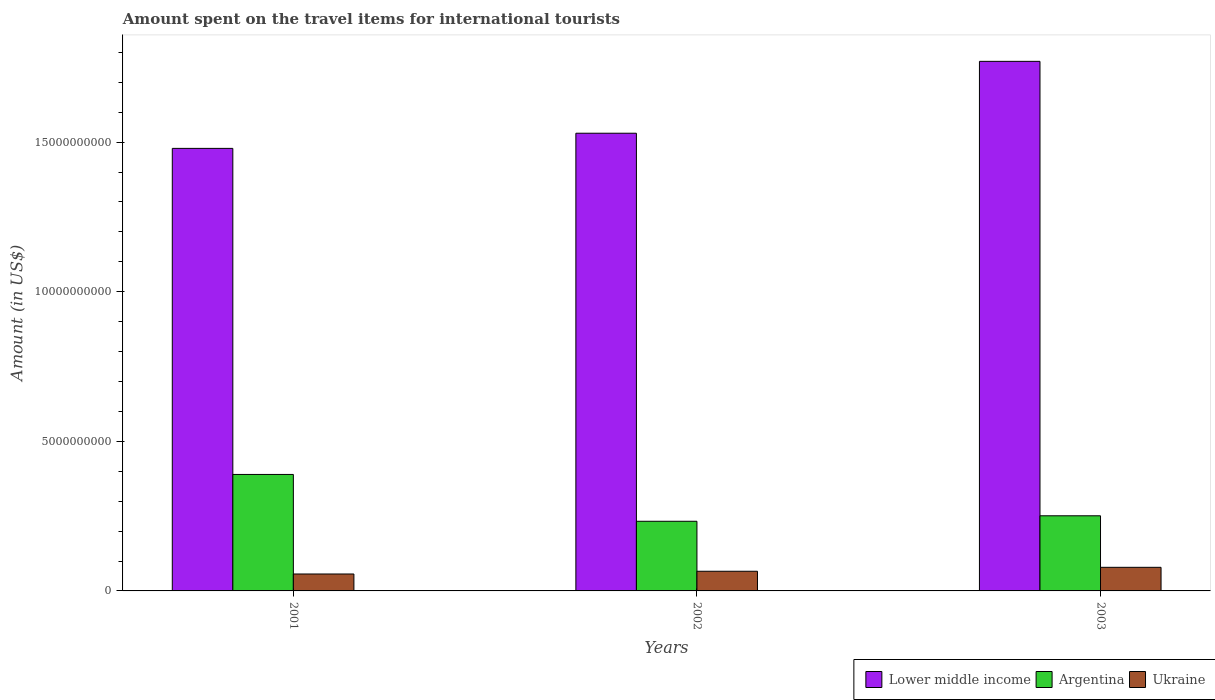How many groups of bars are there?
Offer a very short reply. 3. Are the number of bars per tick equal to the number of legend labels?
Give a very brief answer. Yes. Are the number of bars on each tick of the X-axis equal?
Your answer should be compact. Yes. How many bars are there on the 3rd tick from the left?
Your answer should be compact. 3. In how many cases, is the number of bars for a given year not equal to the number of legend labels?
Your answer should be very brief. 0. What is the amount spent on the travel items for international tourists in Argentina in 2001?
Keep it short and to the point. 3.89e+09. Across all years, what is the maximum amount spent on the travel items for international tourists in Argentina?
Ensure brevity in your answer.  3.89e+09. Across all years, what is the minimum amount spent on the travel items for international tourists in Argentina?
Your answer should be very brief. 2.33e+09. In which year was the amount spent on the travel items for international tourists in Argentina maximum?
Ensure brevity in your answer.  2001. What is the total amount spent on the travel items for international tourists in Lower middle income in the graph?
Your answer should be compact. 4.78e+1. What is the difference between the amount spent on the travel items for international tourists in Lower middle income in 2001 and that in 2003?
Offer a terse response. -2.91e+09. What is the difference between the amount spent on the travel items for international tourists in Argentina in 2003 and the amount spent on the travel items for international tourists in Ukraine in 2002?
Your answer should be compact. 1.85e+09. What is the average amount spent on the travel items for international tourists in Argentina per year?
Keep it short and to the point. 2.91e+09. In the year 2001, what is the difference between the amount spent on the travel items for international tourists in Ukraine and amount spent on the travel items for international tourists in Lower middle income?
Give a very brief answer. -1.42e+1. In how many years, is the amount spent on the travel items for international tourists in Ukraine greater than 16000000000 US$?
Offer a very short reply. 0. What is the ratio of the amount spent on the travel items for international tourists in Lower middle income in 2001 to that in 2003?
Ensure brevity in your answer.  0.84. What is the difference between the highest and the second highest amount spent on the travel items for international tourists in Lower middle income?
Keep it short and to the point. 2.40e+09. What is the difference between the highest and the lowest amount spent on the travel items for international tourists in Lower middle income?
Your answer should be very brief. 2.91e+09. Is the sum of the amount spent on the travel items for international tourists in Lower middle income in 2001 and 2002 greater than the maximum amount spent on the travel items for international tourists in Argentina across all years?
Provide a succinct answer. Yes. What does the 1st bar from the left in 2003 represents?
Keep it short and to the point. Lower middle income. What does the 3rd bar from the right in 2001 represents?
Provide a short and direct response. Lower middle income. Is it the case that in every year, the sum of the amount spent on the travel items for international tourists in Lower middle income and amount spent on the travel items for international tourists in Ukraine is greater than the amount spent on the travel items for international tourists in Argentina?
Your response must be concise. Yes. How many bars are there?
Keep it short and to the point. 9. How many years are there in the graph?
Give a very brief answer. 3. What is the difference between two consecutive major ticks on the Y-axis?
Keep it short and to the point. 5.00e+09. Are the values on the major ticks of Y-axis written in scientific E-notation?
Provide a succinct answer. No. Where does the legend appear in the graph?
Give a very brief answer. Bottom right. What is the title of the graph?
Give a very brief answer. Amount spent on the travel items for international tourists. What is the label or title of the X-axis?
Your response must be concise. Years. What is the Amount (in US$) of Lower middle income in 2001?
Make the answer very short. 1.48e+1. What is the Amount (in US$) in Argentina in 2001?
Offer a terse response. 3.89e+09. What is the Amount (in US$) in Ukraine in 2001?
Ensure brevity in your answer.  5.66e+08. What is the Amount (in US$) of Lower middle income in 2002?
Give a very brief answer. 1.53e+1. What is the Amount (in US$) of Argentina in 2002?
Ensure brevity in your answer.  2.33e+09. What is the Amount (in US$) of Ukraine in 2002?
Keep it short and to the point. 6.57e+08. What is the Amount (in US$) of Lower middle income in 2003?
Give a very brief answer. 1.77e+1. What is the Amount (in US$) in Argentina in 2003?
Your response must be concise. 2.51e+09. What is the Amount (in US$) in Ukraine in 2003?
Offer a very short reply. 7.89e+08. Across all years, what is the maximum Amount (in US$) of Lower middle income?
Make the answer very short. 1.77e+1. Across all years, what is the maximum Amount (in US$) of Argentina?
Your answer should be compact. 3.89e+09. Across all years, what is the maximum Amount (in US$) of Ukraine?
Provide a succinct answer. 7.89e+08. Across all years, what is the minimum Amount (in US$) of Lower middle income?
Make the answer very short. 1.48e+1. Across all years, what is the minimum Amount (in US$) in Argentina?
Offer a very short reply. 2.33e+09. Across all years, what is the minimum Amount (in US$) of Ukraine?
Your answer should be very brief. 5.66e+08. What is the total Amount (in US$) in Lower middle income in the graph?
Provide a short and direct response. 4.78e+1. What is the total Amount (in US$) of Argentina in the graph?
Provide a short and direct response. 8.73e+09. What is the total Amount (in US$) of Ukraine in the graph?
Ensure brevity in your answer.  2.01e+09. What is the difference between the Amount (in US$) in Lower middle income in 2001 and that in 2002?
Offer a terse response. -5.07e+08. What is the difference between the Amount (in US$) in Argentina in 2001 and that in 2002?
Provide a succinct answer. 1.56e+09. What is the difference between the Amount (in US$) of Ukraine in 2001 and that in 2002?
Offer a very short reply. -9.10e+07. What is the difference between the Amount (in US$) of Lower middle income in 2001 and that in 2003?
Your response must be concise. -2.91e+09. What is the difference between the Amount (in US$) of Argentina in 2001 and that in 2003?
Ensure brevity in your answer.  1.38e+09. What is the difference between the Amount (in US$) in Ukraine in 2001 and that in 2003?
Your answer should be very brief. -2.23e+08. What is the difference between the Amount (in US$) in Lower middle income in 2002 and that in 2003?
Provide a short and direct response. -2.40e+09. What is the difference between the Amount (in US$) of Argentina in 2002 and that in 2003?
Provide a succinct answer. -1.83e+08. What is the difference between the Amount (in US$) of Ukraine in 2002 and that in 2003?
Ensure brevity in your answer.  -1.32e+08. What is the difference between the Amount (in US$) of Lower middle income in 2001 and the Amount (in US$) of Argentina in 2002?
Keep it short and to the point. 1.25e+1. What is the difference between the Amount (in US$) in Lower middle income in 2001 and the Amount (in US$) in Ukraine in 2002?
Your answer should be compact. 1.41e+1. What is the difference between the Amount (in US$) of Argentina in 2001 and the Amount (in US$) of Ukraine in 2002?
Your answer should be very brief. 3.24e+09. What is the difference between the Amount (in US$) in Lower middle income in 2001 and the Amount (in US$) in Argentina in 2003?
Keep it short and to the point. 1.23e+1. What is the difference between the Amount (in US$) in Lower middle income in 2001 and the Amount (in US$) in Ukraine in 2003?
Offer a terse response. 1.40e+1. What is the difference between the Amount (in US$) of Argentina in 2001 and the Amount (in US$) of Ukraine in 2003?
Your response must be concise. 3.10e+09. What is the difference between the Amount (in US$) in Lower middle income in 2002 and the Amount (in US$) in Argentina in 2003?
Keep it short and to the point. 1.28e+1. What is the difference between the Amount (in US$) in Lower middle income in 2002 and the Amount (in US$) in Ukraine in 2003?
Ensure brevity in your answer.  1.45e+1. What is the difference between the Amount (in US$) of Argentina in 2002 and the Amount (in US$) of Ukraine in 2003?
Offer a very short reply. 1.54e+09. What is the average Amount (in US$) of Lower middle income per year?
Offer a terse response. 1.59e+1. What is the average Amount (in US$) in Argentina per year?
Keep it short and to the point. 2.91e+09. What is the average Amount (in US$) in Ukraine per year?
Your response must be concise. 6.71e+08. In the year 2001, what is the difference between the Amount (in US$) of Lower middle income and Amount (in US$) of Argentina?
Give a very brief answer. 1.09e+1. In the year 2001, what is the difference between the Amount (in US$) of Lower middle income and Amount (in US$) of Ukraine?
Your answer should be compact. 1.42e+1. In the year 2001, what is the difference between the Amount (in US$) in Argentina and Amount (in US$) in Ukraine?
Your response must be concise. 3.33e+09. In the year 2002, what is the difference between the Amount (in US$) of Lower middle income and Amount (in US$) of Argentina?
Offer a very short reply. 1.30e+1. In the year 2002, what is the difference between the Amount (in US$) of Lower middle income and Amount (in US$) of Ukraine?
Give a very brief answer. 1.46e+1. In the year 2002, what is the difference between the Amount (in US$) of Argentina and Amount (in US$) of Ukraine?
Give a very brief answer. 1.67e+09. In the year 2003, what is the difference between the Amount (in US$) of Lower middle income and Amount (in US$) of Argentina?
Give a very brief answer. 1.52e+1. In the year 2003, what is the difference between the Amount (in US$) of Lower middle income and Amount (in US$) of Ukraine?
Provide a short and direct response. 1.69e+1. In the year 2003, what is the difference between the Amount (in US$) in Argentina and Amount (in US$) in Ukraine?
Ensure brevity in your answer.  1.72e+09. What is the ratio of the Amount (in US$) of Lower middle income in 2001 to that in 2002?
Offer a very short reply. 0.97. What is the ratio of the Amount (in US$) of Argentina in 2001 to that in 2002?
Provide a succinct answer. 1.67. What is the ratio of the Amount (in US$) in Ukraine in 2001 to that in 2002?
Ensure brevity in your answer.  0.86. What is the ratio of the Amount (in US$) of Lower middle income in 2001 to that in 2003?
Keep it short and to the point. 0.84. What is the ratio of the Amount (in US$) of Argentina in 2001 to that in 2003?
Offer a terse response. 1.55. What is the ratio of the Amount (in US$) in Ukraine in 2001 to that in 2003?
Offer a terse response. 0.72. What is the ratio of the Amount (in US$) in Lower middle income in 2002 to that in 2003?
Keep it short and to the point. 0.86. What is the ratio of the Amount (in US$) of Argentina in 2002 to that in 2003?
Give a very brief answer. 0.93. What is the ratio of the Amount (in US$) in Ukraine in 2002 to that in 2003?
Keep it short and to the point. 0.83. What is the difference between the highest and the second highest Amount (in US$) of Lower middle income?
Your answer should be very brief. 2.40e+09. What is the difference between the highest and the second highest Amount (in US$) of Argentina?
Provide a succinct answer. 1.38e+09. What is the difference between the highest and the second highest Amount (in US$) of Ukraine?
Provide a short and direct response. 1.32e+08. What is the difference between the highest and the lowest Amount (in US$) in Lower middle income?
Offer a terse response. 2.91e+09. What is the difference between the highest and the lowest Amount (in US$) of Argentina?
Provide a short and direct response. 1.56e+09. What is the difference between the highest and the lowest Amount (in US$) of Ukraine?
Offer a very short reply. 2.23e+08. 